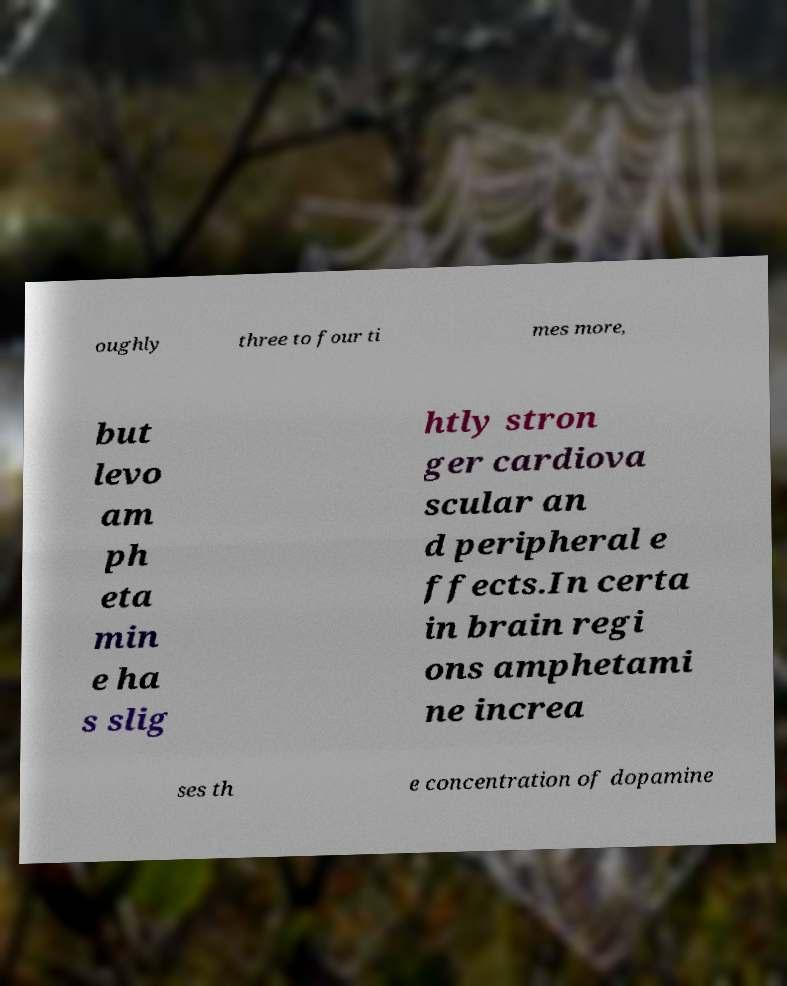I need the written content from this picture converted into text. Can you do that? oughly three to four ti mes more, but levo am ph eta min e ha s slig htly stron ger cardiova scular an d peripheral e ffects.In certa in brain regi ons amphetami ne increa ses th e concentration of dopamine 